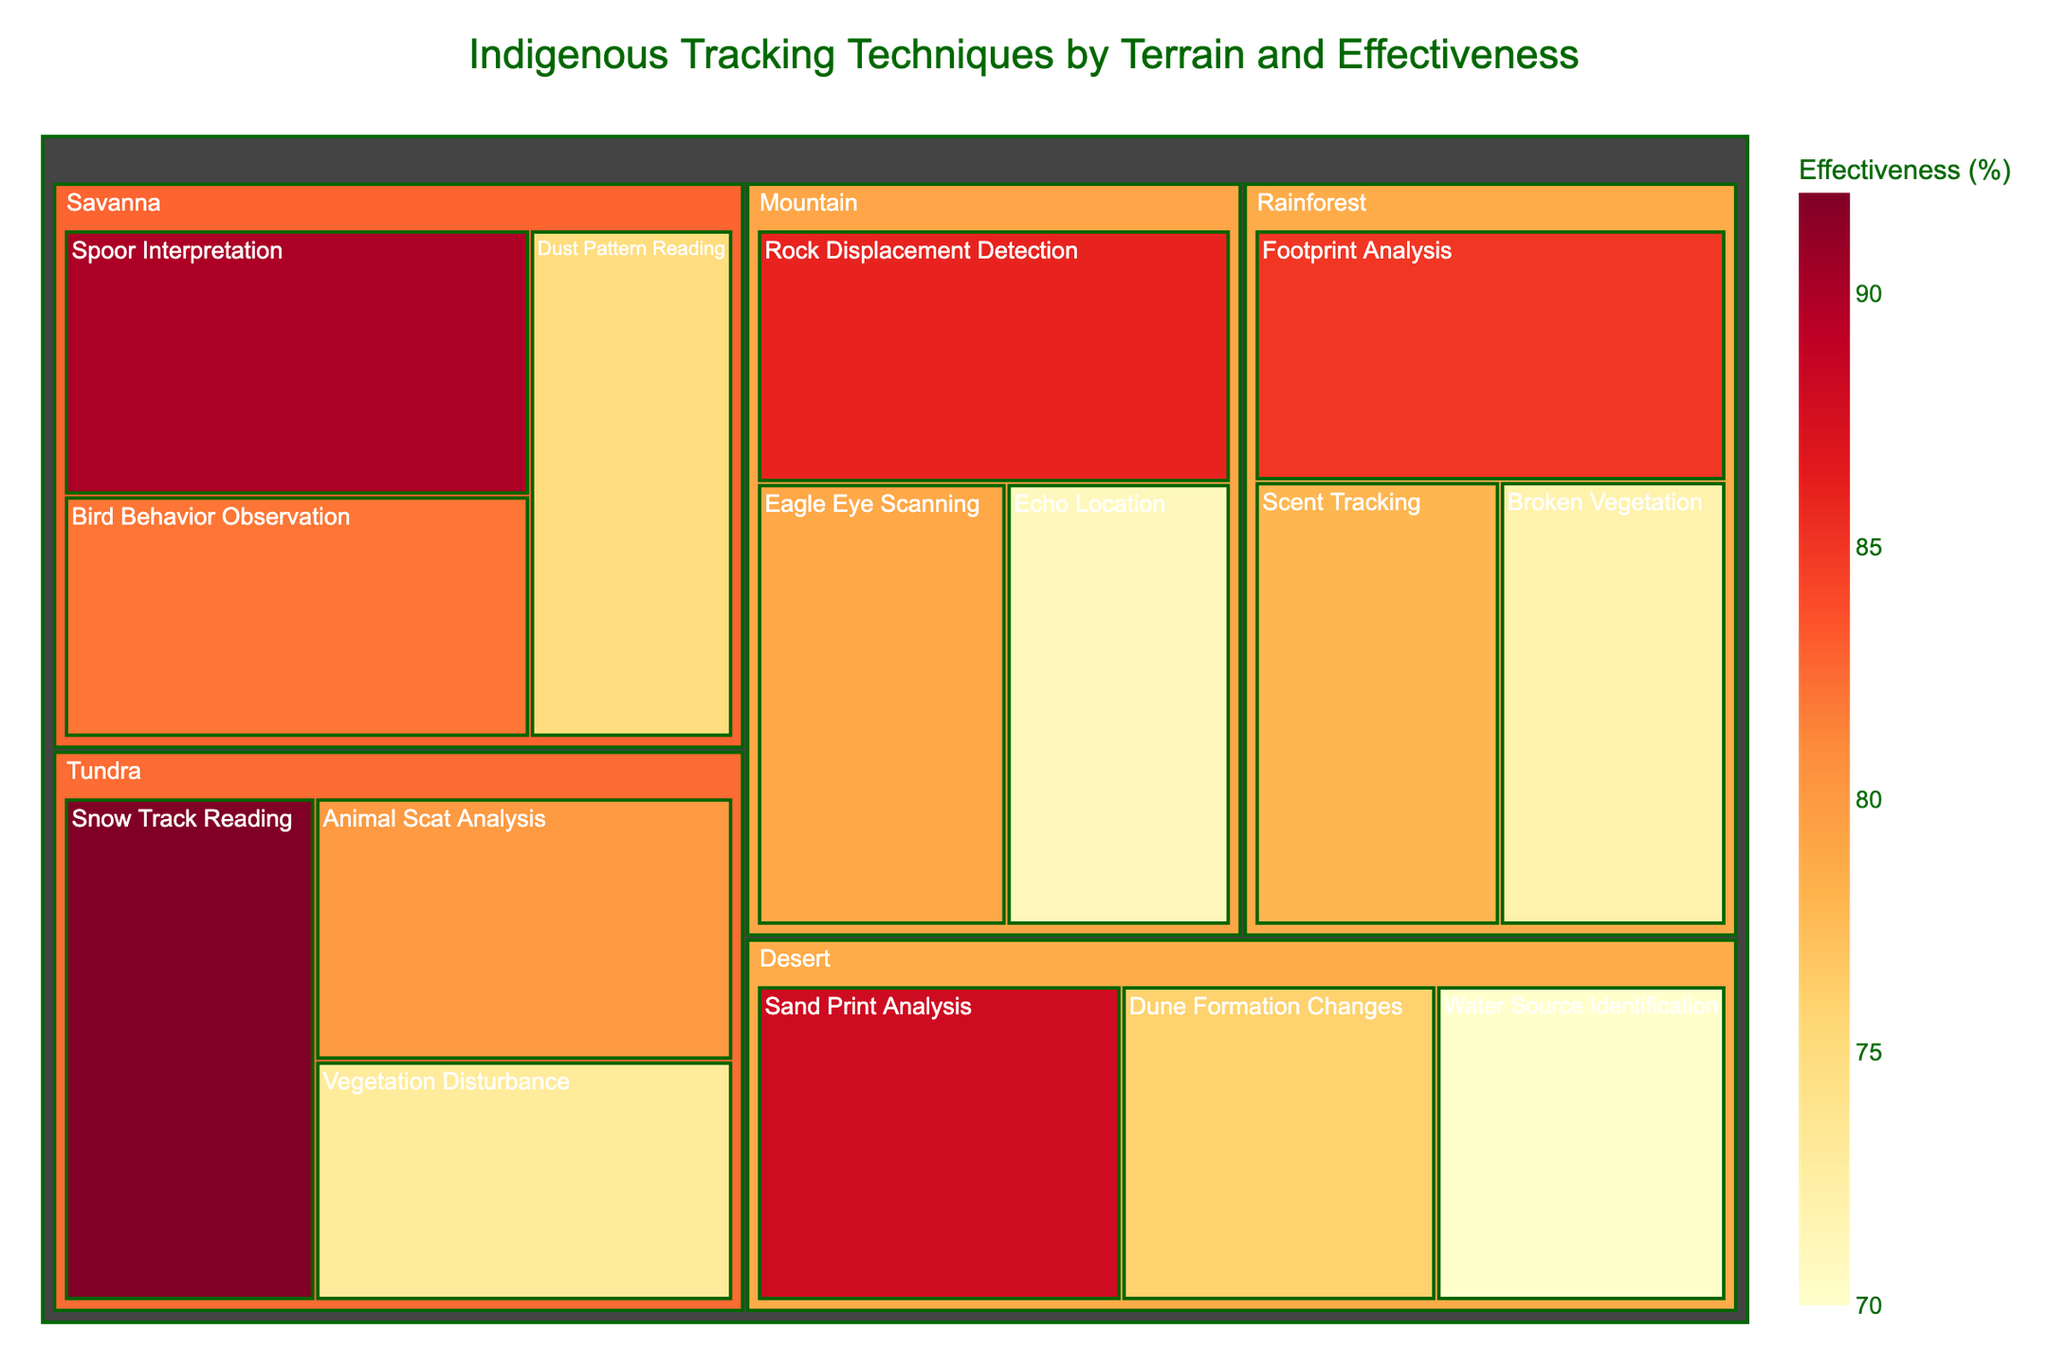What is the title of the treemap? The title is usually displayed at the top of a treemap to give an overview of what the figure is about. In this case, the title summarizes the content being visualized.
Answer: Indigenous Tracking Techniques by Terrain and Effectiveness Which terrain has the most effective tracking technique, and what is it? Look for the terrain category with the highest percentage value. The highest effectiveness indicates the most effective tracking technique.
Answer: Tundra, Snow Track Reading What is the least effective tracking technique in the Desert terrain? Locate the Desert terrain section and compare the effectiveness values of techniques listed under it. The one with the lowest percentage is the least effective.
Answer: Water Source Identification Compare the effectiveness of 'Eagle Eye Scanning' in the Mountain terrain with 'Bird Behavior Observation' in the Savanna terrain. Which one is more effective? Identify the effectiveness percentages for both techniques. Compare the values to determine which is higher.
Answer: Bird Behavior Observation What is the total number of different tracking techniques displayed in the treemap? Count the number of individual techniques listed across all terrains.
Answer: 15 Which tracking technique in the table has the third highest effectiveness? First, identify all the effectiveness values and sort them in descending order. Then determine the technique corresponding to the third highest value. Effectiveness values in descending order: 92, 90, 88, 86. The third highest effectiveness is 88.
Answer: Sand Print Analysis What is the average effectiveness of the tracking techniques in the Tundra terrain? Sum the effectiveness values for the techniques in the Tundra and divide by the number of techniques to get the average. (92 + 80 + 73) / 3 = 245 / 3 = 81.67.
Answer: 81.67 